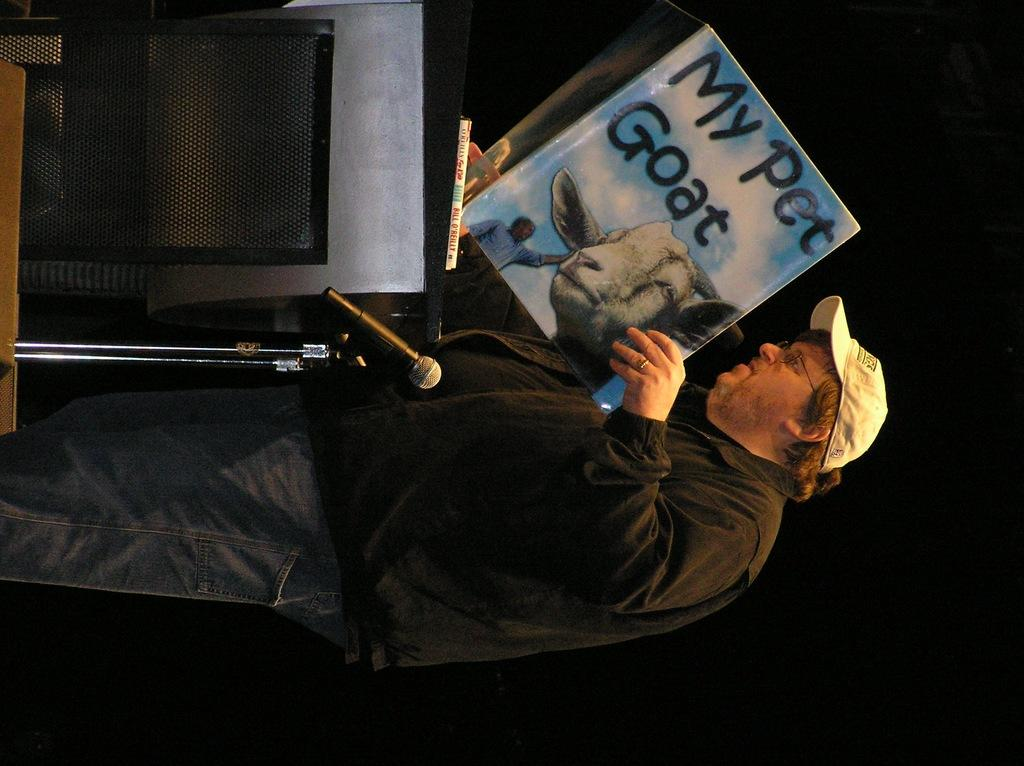<image>
Create a compact narrative representing the image presented. A man is reading the book 'My Pet Goat'. 